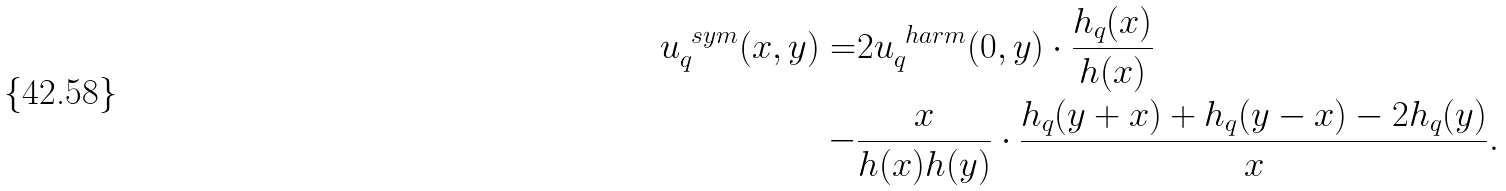<formula> <loc_0><loc_0><loc_500><loc_500>u ^ { \ s y m } _ { q } ( x , y ) = & 2 u ^ { \ h a r m } _ { q } ( 0 , y ) \cdot \frac { h _ { q } ( x ) } { h ( x ) } \\ - & \frac { x } { h ( x ) h ( y ) } \cdot \frac { h _ { q } ( y + x ) + h _ { q } ( y - x ) - 2 h _ { q } ( y ) } { x } .</formula> 